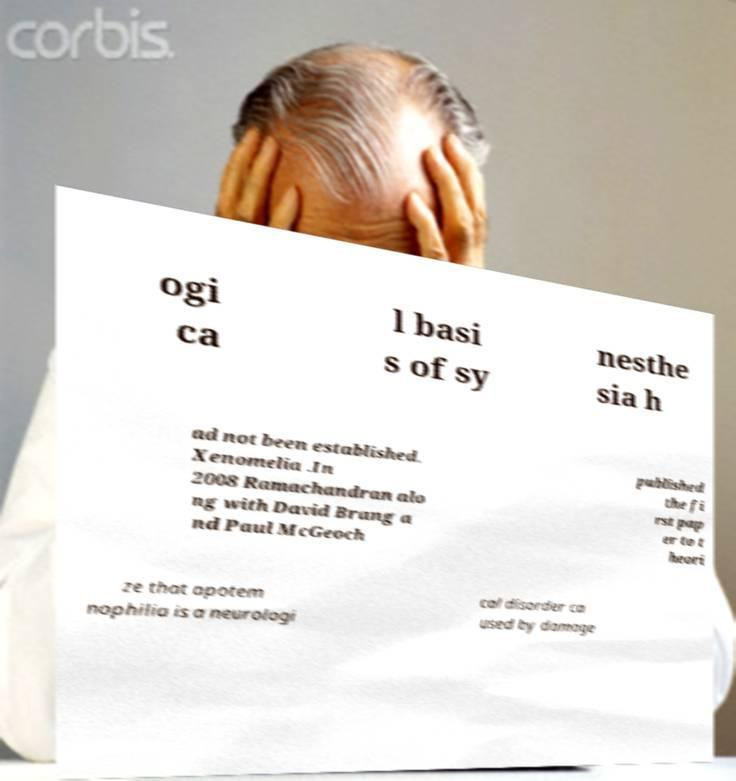Can you accurately transcribe the text from the provided image for me? ogi ca l basi s of sy nesthe sia h ad not been established. Xenomelia .In 2008 Ramachandran alo ng with David Brang a nd Paul McGeoch published the fi rst pap er to t heori ze that apotem nophilia is a neurologi cal disorder ca used by damage 